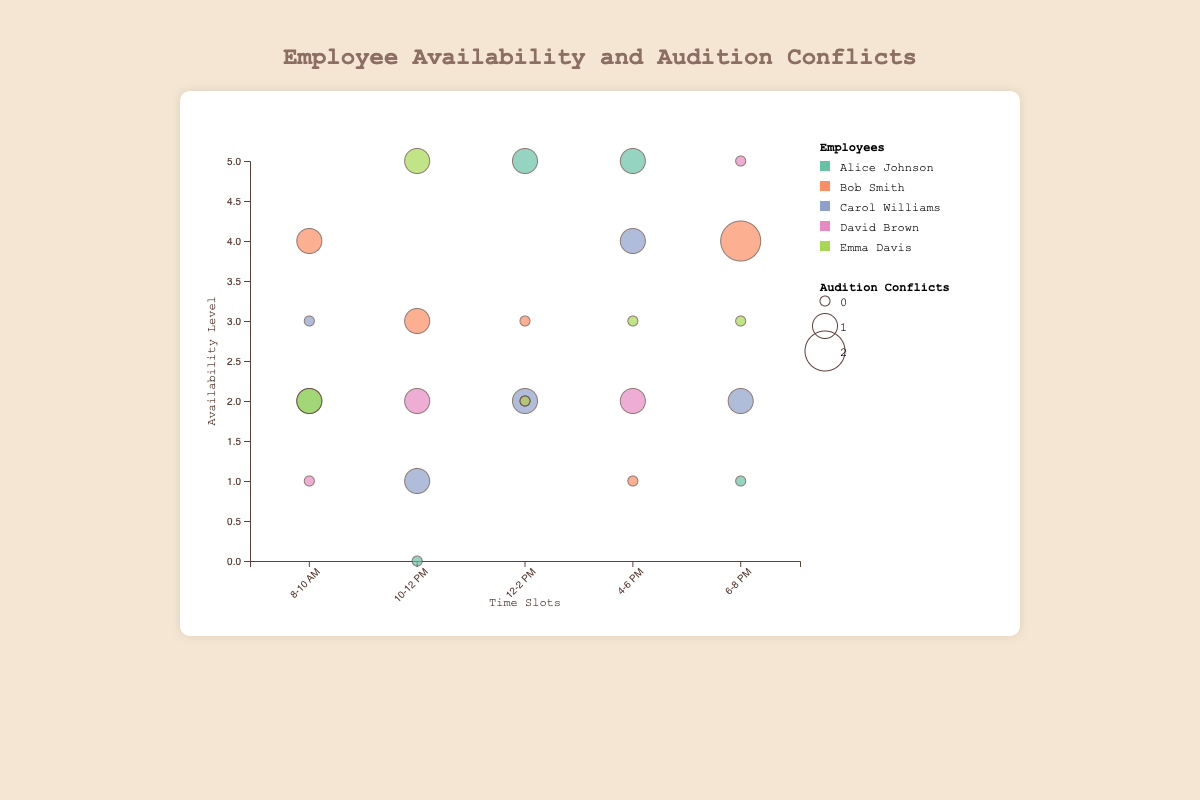What is the title of the chart? The title of the chart is displayed at the top and it reads, "Employee Availability and Audition Conflicts".
Answer: Employee Availability and Audition Conflicts What is the x-axis label and what does it represent? The x-axis label is located at the bottom center of the chart and it reads, "Time Slots", representing the different periods of time throughout the day.
Answer: Time Slots What role has the highest availability between 12-2 PM? By looking at the size of the bubbles at the 12-2 PM time slot, Alice Johnson as a Barista has the highest availability with a value of 5.
Answer: Barista How many bubbles represent availability levels for the time slot 4-6 PM? Each employee has a bubble for every time slot they are available. There are five employees, so there are 5 bubbles representing availability at the 4-6 PM time slot.
Answer: 5 Which employee has the least conflicts at the 8-10 AM time slot and what is their role? Examining the size of the bubbles at the 8-10 AM slot reveals that David Brown, the Manager, has the smallest bubble indicating 0 conflicts.
Answer: David Brown, Manager Which time slot has the highest cumulative availability? By adding up the availability values for each employee in each time slot: 8-10 AM: 2+4+3+1+2=12, 10-12 PM: 0+3+1+2+5=11, 12-2 PM: 5+3+2+2+2=14, 4-6 PM: 5+1+4+2+3=15, 6-8 PM: 1+4+2+5+3=15. The time slots 4-6 PM and 6-8 PM both have the highest total availability of 15.
Answer: 4-6 PM and 6-8 PM Which employee has the most conflicts in the 6-8 PM slot, and what is their audition conflicts value? Observing the size of the bubbles in the 6-8 PM slot, Bob Smith as a Waiter has the largest bubble size with 2 conflicts.
Answer: Bob Smith, 2 What is the average availability for Carol Williams across all time slots? Summing up Carol's availability values: 3+1+2+4+2=12, and she has 5 time slots, the average is 12/5 = 2.4
Answer: 2.4 Who has the largest bubble in the 10-12 PM slot and what does it indicate? Observing the bubbles in the 10-12 PM slot, Emma Davis has the largest bubble size, indicating 1 conflict.
Answer: Emma Davis, 1 What is the relationship between availability and audition conflicts for Alice Johnson in the 12-2 PM time slot? Alice Johnson has an availability value of 5 and a conflict value of 1 in the 12-2 PM time slot. Observing the chart reveals the availability is relatively high despite having one conflict.
Answer: 5 availability, 1 conflict 